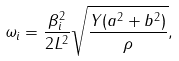Convert formula to latex. <formula><loc_0><loc_0><loc_500><loc_500>\omega _ { i } = \frac { \beta ^ { 2 } _ { i } } { 2 L ^ { 2 } } \sqrt { \frac { Y ( a ^ { 2 } + b ^ { 2 } ) } { \rho } } ,</formula> 